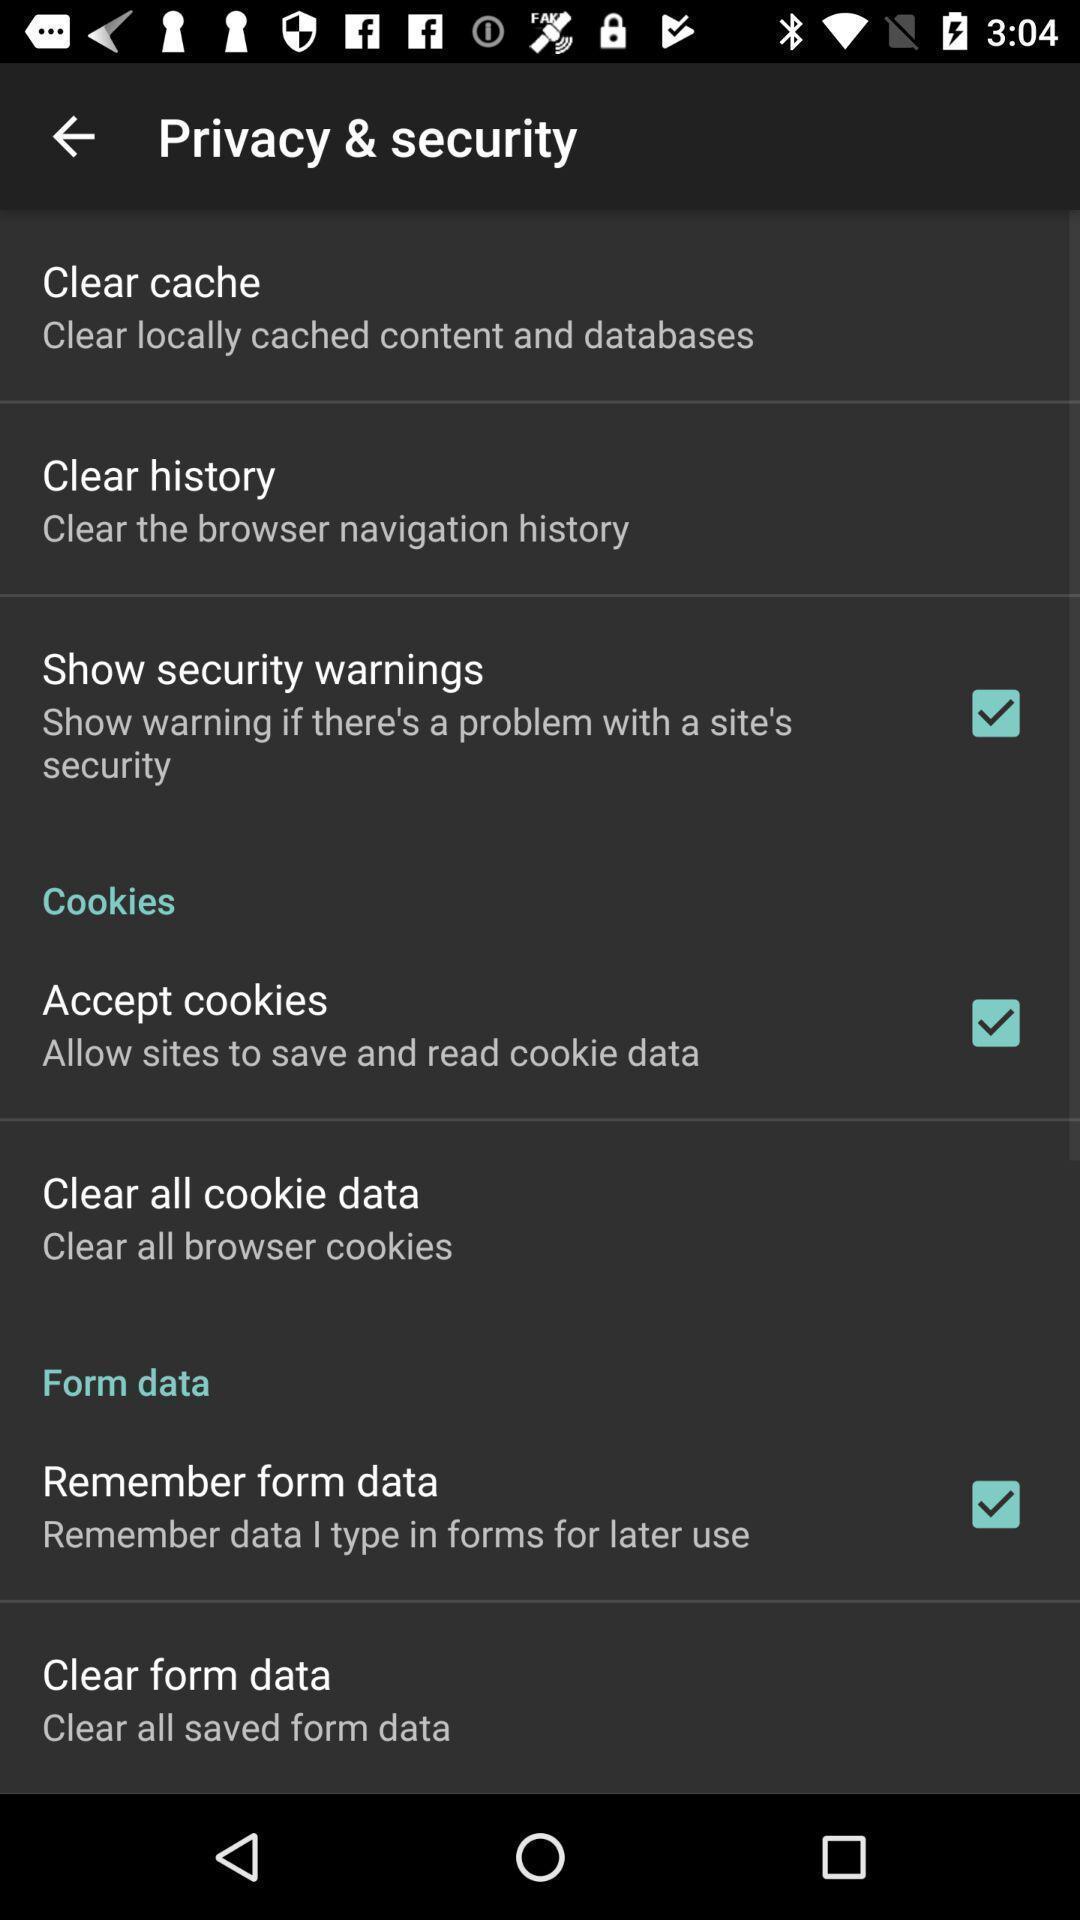Summarize the main components in this picture. Privacy settings page in a social app. 